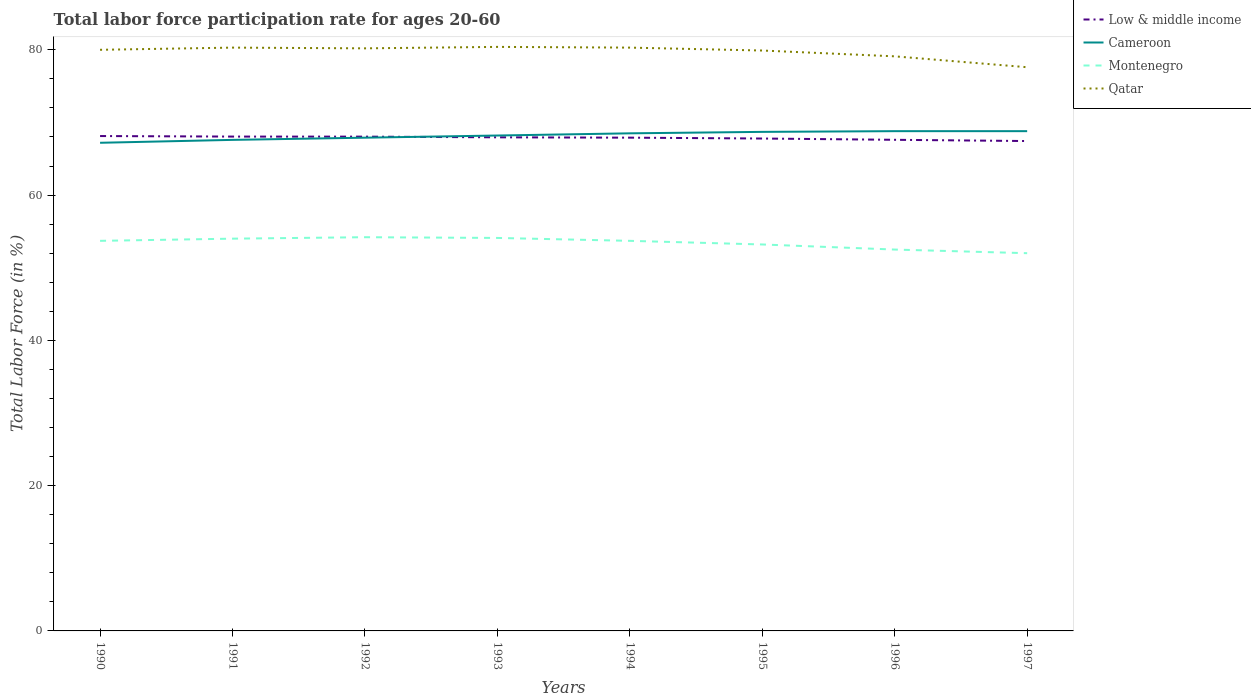Does the line corresponding to Montenegro intersect with the line corresponding to Cameroon?
Ensure brevity in your answer.  No. Is the number of lines equal to the number of legend labels?
Your answer should be compact. Yes. Across all years, what is the maximum labor force participation rate in Qatar?
Provide a succinct answer. 77.6. What is the total labor force participation rate in Montenegro in the graph?
Provide a succinct answer. 2.1. What is the difference between the highest and the second highest labor force participation rate in Montenegro?
Your answer should be very brief. 2.2. Is the labor force participation rate in Low & middle income strictly greater than the labor force participation rate in Montenegro over the years?
Your answer should be compact. No. How many years are there in the graph?
Make the answer very short. 8. What is the difference between two consecutive major ticks on the Y-axis?
Offer a terse response. 20. Does the graph contain any zero values?
Offer a very short reply. No. How many legend labels are there?
Your response must be concise. 4. How are the legend labels stacked?
Keep it short and to the point. Vertical. What is the title of the graph?
Your response must be concise. Total labor force participation rate for ages 20-60. What is the label or title of the Y-axis?
Give a very brief answer. Total Labor Force (in %). What is the Total Labor Force (in %) of Low & middle income in 1990?
Offer a terse response. 68.13. What is the Total Labor Force (in %) of Cameroon in 1990?
Provide a short and direct response. 67.2. What is the Total Labor Force (in %) in Montenegro in 1990?
Offer a very short reply. 53.7. What is the Total Labor Force (in %) in Low & middle income in 1991?
Your answer should be compact. 68.05. What is the Total Labor Force (in %) in Cameroon in 1991?
Your answer should be very brief. 67.6. What is the Total Labor Force (in %) of Qatar in 1991?
Your answer should be very brief. 80.3. What is the Total Labor Force (in %) of Low & middle income in 1992?
Provide a short and direct response. 68.05. What is the Total Labor Force (in %) in Cameroon in 1992?
Give a very brief answer. 67.9. What is the Total Labor Force (in %) in Montenegro in 1992?
Your response must be concise. 54.2. What is the Total Labor Force (in %) in Qatar in 1992?
Provide a succinct answer. 80.2. What is the Total Labor Force (in %) in Low & middle income in 1993?
Provide a short and direct response. 67.95. What is the Total Labor Force (in %) in Cameroon in 1993?
Ensure brevity in your answer.  68.2. What is the Total Labor Force (in %) of Montenegro in 1993?
Make the answer very short. 54.1. What is the Total Labor Force (in %) in Qatar in 1993?
Offer a terse response. 80.4. What is the Total Labor Force (in %) in Low & middle income in 1994?
Give a very brief answer. 67.9. What is the Total Labor Force (in %) in Cameroon in 1994?
Keep it short and to the point. 68.5. What is the Total Labor Force (in %) in Montenegro in 1994?
Make the answer very short. 53.7. What is the Total Labor Force (in %) of Qatar in 1994?
Make the answer very short. 80.3. What is the Total Labor Force (in %) of Low & middle income in 1995?
Offer a terse response. 67.79. What is the Total Labor Force (in %) of Cameroon in 1995?
Your answer should be compact. 68.7. What is the Total Labor Force (in %) in Montenegro in 1995?
Your answer should be compact. 53.2. What is the Total Labor Force (in %) in Qatar in 1995?
Make the answer very short. 79.9. What is the Total Labor Force (in %) of Low & middle income in 1996?
Ensure brevity in your answer.  67.61. What is the Total Labor Force (in %) in Cameroon in 1996?
Provide a short and direct response. 68.8. What is the Total Labor Force (in %) of Montenegro in 1996?
Make the answer very short. 52.5. What is the Total Labor Force (in %) in Qatar in 1996?
Your answer should be very brief. 79.1. What is the Total Labor Force (in %) in Low & middle income in 1997?
Your answer should be compact. 67.44. What is the Total Labor Force (in %) of Cameroon in 1997?
Your answer should be compact. 68.8. What is the Total Labor Force (in %) in Qatar in 1997?
Your answer should be very brief. 77.6. Across all years, what is the maximum Total Labor Force (in %) in Low & middle income?
Make the answer very short. 68.13. Across all years, what is the maximum Total Labor Force (in %) in Cameroon?
Your response must be concise. 68.8. Across all years, what is the maximum Total Labor Force (in %) of Montenegro?
Your response must be concise. 54.2. Across all years, what is the maximum Total Labor Force (in %) of Qatar?
Your answer should be compact. 80.4. Across all years, what is the minimum Total Labor Force (in %) of Low & middle income?
Give a very brief answer. 67.44. Across all years, what is the minimum Total Labor Force (in %) in Cameroon?
Offer a very short reply. 67.2. Across all years, what is the minimum Total Labor Force (in %) in Montenegro?
Offer a very short reply. 52. Across all years, what is the minimum Total Labor Force (in %) of Qatar?
Your answer should be compact. 77.6. What is the total Total Labor Force (in %) of Low & middle income in the graph?
Keep it short and to the point. 542.91. What is the total Total Labor Force (in %) in Cameroon in the graph?
Make the answer very short. 545.7. What is the total Total Labor Force (in %) in Montenegro in the graph?
Make the answer very short. 427.4. What is the total Total Labor Force (in %) in Qatar in the graph?
Provide a short and direct response. 637.8. What is the difference between the Total Labor Force (in %) of Low & middle income in 1990 and that in 1991?
Make the answer very short. 0.07. What is the difference between the Total Labor Force (in %) in Cameroon in 1990 and that in 1991?
Give a very brief answer. -0.4. What is the difference between the Total Labor Force (in %) of Montenegro in 1990 and that in 1991?
Keep it short and to the point. -0.3. What is the difference between the Total Labor Force (in %) of Qatar in 1990 and that in 1991?
Your answer should be compact. -0.3. What is the difference between the Total Labor Force (in %) of Low & middle income in 1990 and that in 1992?
Your response must be concise. 0.08. What is the difference between the Total Labor Force (in %) of Montenegro in 1990 and that in 1992?
Provide a succinct answer. -0.5. What is the difference between the Total Labor Force (in %) of Low & middle income in 1990 and that in 1993?
Give a very brief answer. 0.18. What is the difference between the Total Labor Force (in %) of Cameroon in 1990 and that in 1993?
Keep it short and to the point. -1. What is the difference between the Total Labor Force (in %) in Montenegro in 1990 and that in 1993?
Provide a short and direct response. -0.4. What is the difference between the Total Labor Force (in %) of Qatar in 1990 and that in 1993?
Your answer should be very brief. -0.4. What is the difference between the Total Labor Force (in %) in Low & middle income in 1990 and that in 1994?
Provide a short and direct response. 0.22. What is the difference between the Total Labor Force (in %) in Cameroon in 1990 and that in 1994?
Ensure brevity in your answer.  -1.3. What is the difference between the Total Labor Force (in %) of Montenegro in 1990 and that in 1994?
Your response must be concise. 0. What is the difference between the Total Labor Force (in %) in Low & middle income in 1990 and that in 1995?
Offer a very short reply. 0.34. What is the difference between the Total Labor Force (in %) of Montenegro in 1990 and that in 1995?
Offer a very short reply. 0.5. What is the difference between the Total Labor Force (in %) of Low & middle income in 1990 and that in 1996?
Make the answer very short. 0.52. What is the difference between the Total Labor Force (in %) in Cameroon in 1990 and that in 1996?
Give a very brief answer. -1.6. What is the difference between the Total Labor Force (in %) in Qatar in 1990 and that in 1996?
Offer a terse response. 0.9. What is the difference between the Total Labor Force (in %) in Low & middle income in 1990 and that in 1997?
Give a very brief answer. 0.69. What is the difference between the Total Labor Force (in %) in Low & middle income in 1991 and that in 1992?
Your answer should be compact. 0.01. What is the difference between the Total Labor Force (in %) in Cameroon in 1991 and that in 1992?
Give a very brief answer. -0.3. What is the difference between the Total Labor Force (in %) in Montenegro in 1991 and that in 1992?
Provide a short and direct response. -0.2. What is the difference between the Total Labor Force (in %) in Low & middle income in 1991 and that in 1993?
Your answer should be compact. 0.1. What is the difference between the Total Labor Force (in %) of Cameroon in 1991 and that in 1993?
Give a very brief answer. -0.6. What is the difference between the Total Labor Force (in %) in Montenegro in 1991 and that in 1993?
Your response must be concise. -0.1. What is the difference between the Total Labor Force (in %) in Low & middle income in 1991 and that in 1994?
Provide a short and direct response. 0.15. What is the difference between the Total Labor Force (in %) in Qatar in 1991 and that in 1994?
Provide a short and direct response. 0. What is the difference between the Total Labor Force (in %) in Low & middle income in 1991 and that in 1995?
Make the answer very short. 0.27. What is the difference between the Total Labor Force (in %) of Low & middle income in 1991 and that in 1996?
Offer a terse response. 0.44. What is the difference between the Total Labor Force (in %) in Low & middle income in 1991 and that in 1997?
Keep it short and to the point. 0.62. What is the difference between the Total Labor Force (in %) in Cameroon in 1991 and that in 1997?
Make the answer very short. -1.2. What is the difference between the Total Labor Force (in %) of Montenegro in 1991 and that in 1997?
Your response must be concise. 2. What is the difference between the Total Labor Force (in %) of Qatar in 1991 and that in 1997?
Ensure brevity in your answer.  2.7. What is the difference between the Total Labor Force (in %) of Low & middle income in 1992 and that in 1993?
Give a very brief answer. 0.1. What is the difference between the Total Labor Force (in %) of Cameroon in 1992 and that in 1993?
Your answer should be compact. -0.3. What is the difference between the Total Labor Force (in %) in Qatar in 1992 and that in 1993?
Your answer should be compact. -0.2. What is the difference between the Total Labor Force (in %) of Low & middle income in 1992 and that in 1994?
Ensure brevity in your answer.  0.14. What is the difference between the Total Labor Force (in %) in Cameroon in 1992 and that in 1994?
Offer a very short reply. -0.6. What is the difference between the Total Labor Force (in %) in Montenegro in 1992 and that in 1994?
Keep it short and to the point. 0.5. What is the difference between the Total Labor Force (in %) in Low & middle income in 1992 and that in 1995?
Make the answer very short. 0.26. What is the difference between the Total Labor Force (in %) in Low & middle income in 1992 and that in 1996?
Make the answer very short. 0.44. What is the difference between the Total Labor Force (in %) of Montenegro in 1992 and that in 1996?
Offer a terse response. 1.7. What is the difference between the Total Labor Force (in %) of Qatar in 1992 and that in 1996?
Your answer should be very brief. 1.1. What is the difference between the Total Labor Force (in %) of Low & middle income in 1992 and that in 1997?
Give a very brief answer. 0.61. What is the difference between the Total Labor Force (in %) in Montenegro in 1992 and that in 1997?
Keep it short and to the point. 2.2. What is the difference between the Total Labor Force (in %) in Qatar in 1992 and that in 1997?
Your answer should be compact. 2.6. What is the difference between the Total Labor Force (in %) in Low & middle income in 1993 and that in 1994?
Ensure brevity in your answer.  0.05. What is the difference between the Total Labor Force (in %) in Cameroon in 1993 and that in 1994?
Keep it short and to the point. -0.3. What is the difference between the Total Labor Force (in %) of Low & middle income in 1993 and that in 1995?
Your answer should be compact. 0.17. What is the difference between the Total Labor Force (in %) of Cameroon in 1993 and that in 1995?
Provide a short and direct response. -0.5. What is the difference between the Total Labor Force (in %) in Montenegro in 1993 and that in 1995?
Keep it short and to the point. 0.9. What is the difference between the Total Labor Force (in %) in Low & middle income in 1993 and that in 1996?
Your response must be concise. 0.34. What is the difference between the Total Labor Force (in %) in Cameroon in 1993 and that in 1996?
Provide a succinct answer. -0.6. What is the difference between the Total Labor Force (in %) of Montenegro in 1993 and that in 1996?
Ensure brevity in your answer.  1.6. What is the difference between the Total Labor Force (in %) in Qatar in 1993 and that in 1996?
Ensure brevity in your answer.  1.3. What is the difference between the Total Labor Force (in %) of Low & middle income in 1993 and that in 1997?
Offer a terse response. 0.51. What is the difference between the Total Labor Force (in %) of Montenegro in 1993 and that in 1997?
Make the answer very short. 2.1. What is the difference between the Total Labor Force (in %) of Qatar in 1993 and that in 1997?
Your answer should be compact. 2.8. What is the difference between the Total Labor Force (in %) in Low & middle income in 1994 and that in 1995?
Provide a succinct answer. 0.12. What is the difference between the Total Labor Force (in %) of Qatar in 1994 and that in 1995?
Your answer should be very brief. 0.4. What is the difference between the Total Labor Force (in %) of Low & middle income in 1994 and that in 1996?
Ensure brevity in your answer.  0.29. What is the difference between the Total Labor Force (in %) in Montenegro in 1994 and that in 1996?
Your response must be concise. 1.2. What is the difference between the Total Labor Force (in %) in Qatar in 1994 and that in 1996?
Your answer should be compact. 1.2. What is the difference between the Total Labor Force (in %) of Low & middle income in 1994 and that in 1997?
Ensure brevity in your answer.  0.47. What is the difference between the Total Labor Force (in %) in Low & middle income in 1995 and that in 1996?
Keep it short and to the point. 0.18. What is the difference between the Total Labor Force (in %) in Cameroon in 1995 and that in 1996?
Your answer should be very brief. -0.1. What is the difference between the Total Labor Force (in %) of Low & middle income in 1995 and that in 1997?
Offer a terse response. 0.35. What is the difference between the Total Labor Force (in %) of Montenegro in 1995 and that in 1997?
Your response must be concise. 1.2. What is the difference between the Total Labor Force (in %) of Qatar in 1995 and that in 1997?
Offer a terse response. 2.3. What is the difference between the Total Labor Force (in %) of Low & middle income in 1996 and that in 1997?
Your answer should be compact. 0.17. What is the difference between the Total Labor Force (in %) of Cameroon in 1996 and that in 1997?
Offer a terse response. 0. What is the difference between the Total Labor Force (in %) of Low & middle income in 1990 and the Total Labor Force (in %) of Cameroon in 1991?
Provide a succinct answer. 0.53. What is the difference between the Total Labor Force (in %) of Low & middle income in 1990 and the Total Labor Force (in %) of Montenegro in 1991?
Give a very brief answer. 14.13. What is the difference between the Total Labor Force (in %) of Low & middle income in 1990 and the Total Labor Force (in %) of Qatar in 1991?
Your answer should be compact. -12.17. What is the difference between the Total Labor Force (in %) in Montenegro in 1990 and the Total Labor Force (in %) in Qatar in 1991?
Keep it short and to the point. -26.6. What is the difference between the Total Labor Force (in %) of Low & middle income in 1990 and the Total Labor Force (in %) of Cameroon in 1992?
Provide a succinct answer. 0.23. What is the difference between the Total Labor Force (in %) in Low & middle income in 1990 and the Total Labor Force (in %) in Montenegro in 1992?
Your answer should be compact. 13.93. What is the difference between the Total Labor Force (in %) of Low & middle income in 1990 and the Total Labor Force (in %) of Qatar in 1992?
Your answer should be very brief. -12.07. What is the difference between the Total Labor Force (in %) of Montenegro in 1990 and the Total Labor Force (in %) of Qatar in 1992?
Make the answer very short. -26.5. What is the difference between the Total Labor Force (in %) in Low & middle income in 1990 and the Total Labor Force (in %) in Cameroon in 1993?
Your answer should be very brief. -0.07. What is the difference between the Total Labor Force (in %) in Low & middle income in 1990 and the Total Labor Force (in %) in Montenegro in 1993?
Provide a succinct answer. 14.03. What is the difference between the Total Labor Force (in %) of Low & middle income in 1990 and the Total Labor Force (in %) of Qatar in 1993?
Provide a succinct answer. -12.27. What is the difference between the Total Labor Force (in %) in Montenegro in 1990 and the Total Labor Force (in %) in Qatar in 1993?
Offer a very short reply. -26.7. What is the difference between the Total Labor Force (in %) in Low & middle income in 1990 and the Total Labor Force (in %) in Cameroon in 1994?
Your answer should be compact. -0.37. What is the difference between the Total Labor Force (in %) in Low & middle income in 1990 and the Total Labor Force (in %) in Montenegro in 1994?
Keep it short and to the point. 14.43. What is the difference between the Total Labor Force (in %) in Low & middle income in 1990 and the Total Labor Force (in %) in Qatar in 1994?
Give a very brief answer. -12.17. What is the difference between the Total Labor Force (in %) of Cameroon in 1990 and the Total Labor Force (in %) of Montenegro in 1994?
Keep it short and to the point. 13.5. What is the difference between the Total Labor Force (in %) of Montenegro in 1990 and the Total Labor Force (in %) of Qatar in 1994?
Keep it short and to the point. -26.6. What is the difference between the Total Labor Force (in %) in Low & middle income in 1990 and the Total Labor Force (in %) in Cameroon in 1995?
Your answer should be compact. -0.57. What is the difference between the Total Labor Force (in %) of Low & middle income in 1990 and the Total Labor Force (in %) of Montenegro in 1995?
Offer a very short reply. 14.93. What is the difference between the Total Labor Force (in %) of Low & middle income in 1990 and the Total Labor Force (in %) of Qatar in 1995?
Provide a succinct answer. -11.77. What is the difference between the Total Labor Force (in %) of Cameroon in 1990 and the Total Labor Force (in %) of Qatar in 1995?
Your answer should be compact. -12.7. What is the difference between the Total Labor Force (in %) in Montenegro in 1990 and the Total Labor Force (in %) in Qatar in 1995?
Provide a short and direct response. -26.2. What is the difference between the Total Labor Force (in %) in Low & middle income in 1990 and the Total Labor Force (in %) in Cameroon in 1996?
Your answer should be compact. -0.67. What is the difference between the Total Labor Force (in %) of Low & middle income in 1990 and the Total Labor Force (in %) of Montenegro in 1996?
Give a very brief answer. 15.63. What is the difference between the Total Labor Force (in %) in Low & middle income in 1990 and the Total Labor Force (in %) in Qatar in 1996?
Your answer should be very brief. -10.97. What is the difference between the Total Labor Force (in %) in Cameroon in 1990 and the Total Labor Force (in %) in Montenegro in 1996?
Your answer should be very brief. 14.7. What is the difference between the Total Labor Force (in %) in Montenegro in 1990 and the Total Labor Force (in %) in Qatar in 1996?
Offer a terse response. -25.4. What is the difference between the Total Labor Force (in %) of Low & middle income in 1990 and the Total Labor Force (in %) of Cameroon in 1997?
Offer a very short reply. -0.67. What is the difference between the Total Labor Force (in %) of Low & middle income in 1990 and the Total Labor Force (in %) of Montenegro in 1997?
Ensure brevity in your answer.  16.13. What is the difference between the Total Labor Force (in %) in Low & middle income in 1990 and the Total Labor Force (in %) in Qatar in 1997?
Give a very brief answer. -9.47. What is the difference between the Total Labor Force (in %) of Montenegro in 1990 and the Total Labor Force (in %) of Qatar in 1997?
Your response must be concise. -23.9. What is the difference between the Total Labor Force (in %) in Low & middle income in 1991 and the Total Labor Force (in %) in Cameroon in 1992?
Give a very brief answer. 0.15. What is the difference between the Total Labor Force (in %) in Low & middle income in 1991 and the Total Labor Force (in %) in Montenegro in 1992?
Offer a very short reply. 13.85. What is the difference between the Total Labor Force (in %) in Low & middle income in 1991 and the Total Labor Force (in %) in Qatar in 1992?
Provide a succinct answer. -12.15. What is the difference between the Total Labor Force (in %) in Montenegro in 1991 and the Total Labor Force (in %) in Qatar in 1992?
Your response must be concise. -26.2. What is the difference between the Total Labor Force (in %) in Low & middle income in 1991 and the Total Labor Force (in %) in Cameroon in 1993?
Make the answer very short. -0.15. What is the difference between the Total Labor Force (in %) in Low & middle income in 1991 and the Total Labor Force (in %) in Montenegro in 1993?
Your answer should be very brief. 13.95. What is the difference between the Total Labor Force (in %) in Low & middle income in 1991 and the Total Labor Force (in %) in Qatar in 1993?
Provide a succinct answer. -12.35. What is the difference between the Total Labor Force (in %) in Montenegro in 1991 and the Total Labor Force (in %) in Qatar in 1993?
Offer a terse response. -26.4. What is the difference between the Total Labor Force (in %) of Low & middle income in 1991 and the Total Labor Force (in %) of Cameroon in 1994?
Make the answer very short. -0.45. What is the difference between the Total Labor Force (in %) of Low & middle income in 1991 and the Total Labor Force (in %) of Montenegro in 1994?
Ensure brevity in your answer.  14.35. What is the difference between the Total Labor Force (in %) of Low & middle income in 1991 and the Total Labor Force (in %) of Qatar in 1994?
Offer a very short reply. -12.25. What is the difference between the Total Labor Force (in %) in Cameroon in 1991 and the Total Labor Force (in %) in Qatar in 1994?
Provide a short and direct response. -12.7. What is the difference between the Total Labor Force (in %) of Montenegro in 1991 and the Total Labor Force (in %) of Qatar in 1994?
Provide a short and direct response. -26.3. What is the difference between the Total Labor Force (in %) of Low & middle income in 1991 and the Total Labor Force (in %) of Cameroon in 1995?
Ensure brevity in your answer.  -0.65. What is the difference between the Total Labor Force (in %) of Low & middle income in 1991 and the Total Labor Force (in %) of Montenegro in 1995?
Provide a succinct answer. 14.85. What is the difference between the Total Labor Force (in %) in Low & middle income in 1991 and the Total Labor Force (in %) in Qatar in 1995?
Your answer should be compact. -11.85. What is the difference between the Total Labor Force (in %) in Cameroon in 1991 and the Total Labor Force (in %) in Montenegro in 1995?
Make the answer very short. 14.4. What is the difference between the Total Labor Force (in %) in Montenegro in 1991 and the Total Labor Force (in %) in Qatar in 1995?
Your answer should be compact. -25.9. What is the difference between the Total Labor Force (in %) in Low & middle income in 1991 and the Total Labor Force (in %) in Cameroon in 1996?
Offer a terse response. -0.75. What is the difference between the Total Labor Force (in %) in Low & middle income in 1991 and the Total Labor Force (in %) in Montenegro in 1996?
Provide a succinct answer. 15.55. What is the difference between the Total Labor Force (in %) of Low & middle income in 1991 and the Total Labor Force (in %) of Qatar in 1996?
Offer a terse response. -11.05. What is the difference between the Total Labor Force (in %) in Cameroon in 1991 and the Total Labor Force (in %) in Qatar in 1996?
Provide a short and direct response. -11.5. What is the difference between the Total Labor Force (in %) of Montenegro in 1991 and the Total Labor Force (in %) of Qatar in 1996?
Offer a very short reply. -25.1. What is the difference between the Total Labor Force (in %) in Low & middle income in 1991 and the Total Labor Force (in %) in Cameroon in 1997?
Your answer should be compact. -0.75. What is the difference between the Total Labor Force (in %) of Low & middle income in 1991 and the Total Labor Force (in %) of Montenegro in 1997?
Give a very brief answer. 16.05. What is the difference between the Total Labor Force (in %) in Low & middle income in 1991 and the Total Labor Force (in %) in Qatar in 1997?
Ensure brevity in your answer.  -9.55. What is the difference between the Total Labor Force (in %) in Cameroon in 1991 and the Total Labor Force (in %) in Qatar in 1997?
Keep it short and to the point. -10. What is the difference between the Total Labor Force (in %) in Montenegro in 1991 and the Total Labor Force (in %) in Qatar in 1997?
Offer a terse response. -23.6. What is the difference between the Total Labor Force (in %) of Low & middle income in 1992 and the Total Labor Force (in %) of Cameroon in 1993?
Make the answer very short. -0.15. What is the difference between the Total Labor Force (in %) of Low & middle income in 1992 and the Total Labor Force (in %) of Montenegro in 1993?
Give a very brief answer. 13.95. What is the difference between the Total Labor Force (in %) in Low & middle income in 1992 and the Total Labor Force (in %) in Qatar in 1993?
Your answer should be compact. -12.35. What is the difference between the Total Labor Force (in %) of Cameroon in 1992 and the Total Labor Force (in %) of Montenegro in 1993?
Ensure brevity in your answer.  13.8. What is the difference between the Total Labor Force (in %) of Montenegro in 1992 and the Total Labor Force (in %) of Qatar in 1993?
Offer a terse response. -26.2. What is the difference between the Total Labor Force (in %) of Low & middle income in 1992 and the Total Labor Force (in %) of Cameroon in 1994?
Your answer should be very brief. -0.45. What is the difference between the Total Labor Force (in %) of Low & middle income in 1992 and the Total Labor Force (in %) of Montenegro in 1994?
Offer a very short reply. 14.35. What is the difference between the Total Labor Force (in %) in Low & middle income in 1992 and the Total Labor Force (in %) in Qatar in 1994?
Offer a very short reply. -12.25. What is the difference between the Total Labor Force (in %) in Cameroon in 1992 and the Total Labor Force (in %) in Montenegro in 1994?
Your answer should be compact. 14.2. What is the difference between the Total Labor Force (in %) of Montenegro in 1992 and the Total Labor Force (in %) of Qatar in 1994?
Give a very brief answer. -26.1. What is the difference between the Total Labor Force (in %) of Low & middle income in 1992 and the Total Labor Force (in %) of Cameroon in 1995?
Your response must be concise. -0.65. What is the difference between the Total Labor Force (in %) of Low & middle income in 1992 and the Total Labor Force (in %) of Montenegro in 1995?
Make the answer very short. 14.85. What is the difference between the Total Labor Force (in %) in Low & middle income in 1992 and the Total Labor Force (in %) in Qatar in 1995?
Ensure brevity in your answer.  -11.85. What is the difference between the Total Labor Force (in %) of Cameroon in 1992 and the Total Labor Force (in %) of Montenegro in 1995?
Your answer should be very brief. 14.7. What is the difference between the Total Labor Force (in %) in Montenegro in 1992 and the Total Labor Force (in %) in Qatar in 1995?
Keep it short and to the point. -25.7. What is the difference between the Total Labor Force (in %) in Low & middle income in 1992 and the Total Labor Force (in %) in Cameroon in 1996?
Your response must be concise. -0.75. What is the difference between the Total Labor Force (in %) in Low & middle income in 1992 and the Total Labor Force (in %) in Montenegro in 1996?
Give a very brief answer. 15.55. What is the difference between the Total Labor Force (in %) of Low & middle income in 1992 and the Total Labor Force (in %) of Qatar in 1996?
Your answer should be very brief. -11.05. What is the difference between the Total Labor Force (in %) in Cameroon in 1992 and the Total Labor Force (in %) in Montenegro in 1996?
Keep it short and to the point. 15.4. What is the difference between the Total Labor Force (in %) of Montenegro in 1992 and the Total Labor Force (in %) of Qatar in 1996?
Make the answer very short. -24.9. What is the difference between the Total Labor Force (in %) of Low & middle income in 1992 and the Total Labor Force (in %) of Cameroon in 1997?
Give a very brief answer. -0.75. What is the difference between the Total Labor Force (in %) in Low & middle income in 1992 and the Total Labor Force (in %) in Montenegro in 1997?
Keep it short and to the point. 16.05. What is the difference between the Total Labor Force (in %) of Low & middle income in 1992 and the Total Labor Force (in %) of Qatar in 1997?
Ensure brevity in your answer.  -9.55. What is the difference between the Total Labor Force (in %) of Montenegro in 1992 and the Total Labor Force (in %) of Qatar in 1997?
Provide a short and direct response. -23.4. What is the difference between the Total Labor Force (in %) of Low & middle income in 1993 and the Total Labor Force (in %) of Cameroon in 1994?
Offer a very short reply. -0.55. What is the difference between the Total Labor Force (in %) in Low & middle income in 1993 and the Total Labor Force (in %) in Montenegro in 1994?
Give a very brief answer. 14.25. What is the difference between the Total Labor Force (in %) of Low & middle income in 1993 and the Total Labor Force (in %) of Qatar in 1994?
Keep it short and to the point. -12.35. What is the difference between the Total Labor Force (in %) of Montenegro in 1993 and the Total Labor Force (in %) of Qatar in 1994?
Offer a very short reply. -26.2. What is the difference between the Total Labor Force (in %) in Low & middle income in 1993 and the Total Labor Force (in %) in Cameroon in 1995?
Your answer should be very brief. -0.75. What is the difference between the Total Labor Force (in %) of Low & middle income in 1993 and the Total Labor Force (in %) of Montenegro in 1995?
Your answer should be very brief. 14.75. What is the difference between the Total Labor Force (in %) in Low & middle income in 1993 and the Total Labor Force (in %) in Qatar in 1995?
Offer a very short reply. -11.95. What is the difference between the Total Labor Force (in %) of Montenegro in 1993 and the Total Labor Force (in %) of Qatar in 1995?
Keep it short and to the point. -25.8. What is the difference between the Total Labor Force (in %) in Low & middle income in 1993 and the Total Labor Force (in %) in Cameroon in 1996?
Your response must be concise. -0.85. What is the difference between the Total Labor Force (in %) of Low & middle income in 1993 and the Total Labor Force (in %) of Montenegro in 1996?
Make the answer very short. 15.45. What is the difference between the Total Labor Force (in %) in Low & middle income in 1993 and the Total Labor Force (in %) in Qatar in 1996?
Offer a very short reply. -11.15. What is the difference between the Total Labor Force (in %) of Cameroon in 1993 and the Total Labor Force (in %) of Qatar in 1996?
Keep it short and to the point. -10.9. What is the difference between the Total Labor Force (in %) in Low & middle income in 1993 and the Total Labor Force (in %) in Cameroon in 1997?
Offer a terse response. -0.85. What is the difference between the Total Labor Force (in %) in Low & middle income in 1993 and the Total Labor Force (in %) in Montenegro in 1997?
Make the answer very short. 15.95. What is the difference between the Total Labor Force (in %) in Low & middle income in 1993 and the Total Labor Force (in %) in Qatar in 1997?
Your answer should be very brief. -9.65. What is the difference between the Total Labor Force (in %) of Cameroon in 1993 and the Total Labor Force (in %) of Montenegro in 1997?
Give a very brief answer. 16.2. What is the difference between the Total Labor Force (in %) in Montenegro in 1993 and the Total Labor Force (in %) in Qatar in 1997?
Make the answer very short. -23.5. What is the difference between the Total Labor Force (in %) of Low & middle income in 1994 and the Total Labor Force (in %) of Cameroon in 1995?
Keep it short and to the point. -0.8. What is the difference between the Total Labor Force (in %) of Low & middle income in 1994 and the Total Labor Force (in %) of Montenegro in 1995?
Ensure brevity in your answer.  14.7. What is the difference between the Total Labor Force (in %) of Low & middle income in 1994 and the Total Labor Force (in %) of Qatar in 1995?
Make the answer very short. -12. What is the difference between the Total Labor Force (in %) of Cameroon in 1994 and the Total Labor Force (in %) of Montenegro in 1995?
Your answer should be compact. 15.3. What is the difference between the Total Labor Force (in %) in Montenegro in 1994 and the Total Labor Force (in %) in Qatar in 1995?
Keep it short and to the point. -26.2. What is the difference between the Total Labor Force (in %) in Low & middle income in 1994 and the Total Labor Force (in %) in Cameroon in 1996?
Your answer should be very brief. -0.9. What is the difference between the Total Labor Force (in %) of Low & middle income in 1994 and the Total Labor Force (in %) of Montenegro in 1996?
Provide a short and direct response. 15.4. What is the difference between the Total Labor Force (in %) of Low & middle income in 1994 and the Total Labor Force (in %) of Qatar in 1996?
Your answer should be compact. -11.2. What is the difference between the Total Labor Force (in %) in Montenegro in 1994 and the Total Labor Force (in %) in Qatar in 1996?
Offer a very short reply. -25.4. What is the difference between the Total Labor Force (in %) in Low & middle income in 1994 and the Total Labor Force (in %) in Cameroon in 1997?
Ensure brevity in your answer.  -0.9. What is the difference between the Total Labor Force (in %) of Low & middle income in 1994 and the Total Labor Force (in %) of Montenegro in 1997?
Give a very brief answer. 15.9. What is the difference between the Total Labor Force (in %) of Low & middle income in 1994 and the Total Labor Force (in %) of Qatar in 1997?
Your answer should be compact. -9.7. What is the difference between the Total Labor Force (in %) in Cameroon in 1994 and the Total Labor Force (in %) in Montenegro in 1997?
Offer a terse response. 16.5. What is the difference between the Total Labor Force (in %) in Cameroon in 1994 and the Total Labor Force (in %) in Qatar in 1997?
Make the answer very short. -9.1. What is the difference between the Total Labor Force (in %) in Montenegro in 1994 and the Total Labor Force (in %) in Qatar in 1997?
Make the answer very short. -23.9. What is the difference between the Total Labor Force (in %) of Low & middle income in 1995 and the Total Labor Force (in %) of Cameroon in 1996?
Provide a short and direct response. -1.01. What is the difference between the Total Labor Force (in %) of Low & middle income in 1995 and the Total Labor Force (in %) of Montenegro in 1996?
Your answer should be compact. 15.29. What is the difference between the Total Labor Force (in %) in Low & middle income in 1995 and the Total Labor Force (in %) in Qatar in 1996?
Your response must be concise. -11.31. What is the difference between the Total Labor Force (in %) in Cameroon in 1995 and the Total Labor Force (in %) in Montenegro in 1996?
Provide a succinct answer. 16.2. What is the difference between the Total Labor Force (in %) of Montenegro in 1995 and the Total Labor Force (in %) of Qatar in 1996?
Your response must be concise. -25.9. What is the difference between the Total Labor Force (in %) in Low & middle income in 1995 and the Total Labor Force (in %) in Cameroon in 1997?
Ensure brevity in your answer.  -1.01. What is the difference between the Total Labor Force (in %) in Low & middle income in 1995 and the Total Labor Force (in %) in Montenegro in 1997?
Your answer should be compact. 15.79. What is the difference between the Total Labor Force (in %) in Low & middle income in 1995 and the Total Labor Force (in %) in Qatar in 1997?
Ensure brevity in your answer.  -9.81. What is the difference between the Total Labor Force (in %) of Cameroon in 1995 and the Total Labor Force (in %) of Montenegro in 1997?
Provide a short and direct response. 16.7. What is the difference between the Total Labor Force (in %) in Montenegro in 1995 and the Total Labor Force (in %) in Qatar in 1997?
Keep it short and to the point. -24.4. What is the difference between the Total Labor Force (in %) of Low & middle income in 1996 and the Total Labor Force (in %) of Cameroon in 1997?
Your answer should be very brief. -1.19. What is the difference between the Total Labor Force (in %) in Low & middle income in 1996 and the Total Labor Force (in %) in Montenegro in 1997?
Ensure brevity in your answer.  15.61. What is the difference between the Total Labor Force (in %) of Low & middle income in 1996 and the Total Labor Force (in %) of Qatar in 1997?
Ensure brevity in your answer.  -9.99. What is the difference between the Total Labor Force (in %) in Cameroon in 1996 and the Total Labor Force (in %) in Qatar in 1997?
Ensure brevity in your answer.  -8.8. What is the difference between the Total Labor Force (in %) of Montenegro in 1996 and the Total Labor Force (in %) of Qatar in 1997?
Make the answer very short. -25.1. What is the average Total Labor Force (in %) of Low & middle income per year?
Make the answer very short. 67.86. What is the average Total Labor Force (in %) in Cameroon per year?
Provide a succinct answer. 68.21. What is the average Total Labor Force (in %) in Montenegro per year?
Make the answer very short. 53.42. What is the average Total Labor Force (in %) of Qatar per year?
Ensure brevity in your answer.  79.72. In the year 1990, what is the difference between the Total Labor Force (in %) of Low & middle income and Total Labor Force (in %) of Cameroon?
Give a very brief answer. 0.93. In the year 1990, what is the difference between the Total Labor Force (in %) of Low & middle income and Total Labor Force (in %) of Montenegro?
Provide a succinct answer. 14.43. In the year 1990, what is the difference between the Total Labor Force (in %) of Low & middle income and Total Labor Force (in %) of Qatar?
Give a very brief answer. -11.87. In the year 1990, what is the difference between the Total Labor Force (in %) in Cameroon and Total Labor Force (in %) in Qatar?
Provide a short and direct response. -12.8. In the year 1990, what is the difference between the Total Labor Force (in %) in Montenegro and Total Labor Force (in %) in Qatar?
Offer a terse response. -26.3. In the year 1991, what is the difference between the Total Labor Force (in %) in Low & middle income and Total Labor Force (in %) in Cameroon?
Keep it short and to the point. 0.45. In the year 1991, what is the difference between the Total Labor Force (in %) of Low & middle income and Total Labor Force (in %) of Montenegro?
Your answer should be compact. 14.05. In the year 1991, what is the difference between the Total Labor Force (in %) in Low & middle income and Total Labor Force (in %) in Qatar?
Offer a very short reply. -12.25. In the year 1991, what is the difference between the Total Labor Force (in %) of Cameroon and Total Labor Force (in %) of Montenegro?
Give a very brief answer. 13.6. In the year 1991, what is the difference between the Total Labor Force (in %) in Cameroon and Total Labor Force (in %) in Qatar?
Provide a succinct answer. -12.7. In the year 1991, what is the difference between the Total Labor Force (in %) in Montenegro and Total Labor Force (in %) in Qatar?
Offer a very short reply. -26.3. In the year 1992, what is the difference between the Total Labor Force (in %) in Low & middle income and Total Labor Force (in %) in Cameroon?
Your answer should be very brief. 0.15. In the year 1992, what is the difference between the Total Labor Force (in %) in Low & middle income and Total Labor Force (in %) in Montenegro?
Give a very brief answer. 13.85. In the year 1992, what is the difference between the Total Labor Force (in %) in Low & middle income and Total Labor Force (in %) in Qatar?
Your answer should be compact. -12.15. In the year 1992, what is the difference between the Total Labor Force (in %) of Cameroon and Total Labor Force (in %) of Montenegro?
Offer a terse response. 13.7. In the year 1993, what is the difference between the Total Labor Force (in %) of Low & middle income and Total Labor Force (in %) of Cameroon?
Offer a very short reply. -0.25. In the year 1993, what is the difference between the Total Labor Force (in %) of Low & middle income and Total Labor Force (in %) of Montenegro?
Offer a terse response. 13.85. In the year 1993, what is the difference between the Total Labor Force (in %) in Low & middle income and Total Labor Force (in %) in Qatar?
Your answer should be compact. -12.45. In the year 1993, what is the difference between the Total Labor Force (in %) in Montenegro and Total Labor Force (in %) in Qatar?
Provide a short and direct response. -26.3. In the year 1994, what is the difference between the Total Labor Force (in %) of Low & middle income and Total Labor Force (in %) of Cameroon?
Offer a very short reply. -0.6. In the year 1994, what is the difference between the Total Labor Force (in %) in Low & middle income and Total Labor Force (in %) in Montenegro?
Ensure brevity in your answer.  14.2. In the year 1994, what is the difference between the Total Labor Force (in %) in Low & middle income and Total Labor Force (in %) in Qatar?
Keep it short and to the point. -12.4. In the year 1994, what is the difference between the Total Labor Force (in %) of Montenegro and Total Labor Force (in %) of Qatar?
Provide a succinct answer. -26.6. In the year 1995, what is the difference between the Total Labor Force (in %) in Low & middle income and Total Labor Force (in %) in Cameroon?
Provide a short and direct response. -0.91. In the year 1995, what is the difference between the Total Labor Force (in %) of Low & middle income and Total Labor Force (in %) of Montenegro?
Your answer should be very brief. 14.59. In the year 1995, what is the difference between the Total Labor Force (in %) in Low & middle income and Total Labor Force (in %) in Qatar?
Your response must be concise. -12.11. In the year 1995, what is the difference between the Total Labor Force (in %) in Cameroon and Total Labor Force (in %) in Qatar?
Ensure brevity in your answer.  -11.2. In the year 1995, what is the difference between the Total Labor Force (in %) of Montenegro and Total Labor Force (in %) of Qatar?
Ensure brevity in your answer.  -26.7. In the year 1996, what is the difference between the Total Labor Force (in %) in Low & middle income and Total Labor Force (in %) in Cameroon?
Offer a very short reply. -1.19. In the year 1996, what is the difference between the Total Labor Force (in %) in Low & middle income and Total Labor Force (in %) in Montenegro?
Ensure brevity in your answer.  15.11. In the year 1996, what is the difference between the Total Labor Force (in %) in Low & middle income and Total Labor Force (in %) in Qatar?
Make the answer very short. -11.49. In the year 1996, what is the difference between the Total Labor Force (in %) in Cameroon and Total Labor Force (in %) in Qatar?
Your answer should be very brief. -10.3. In the year 1996, what is the difference between the Total Labor Force (in %) of Montenegro and Total Labor Force (in %) of Qatar?
Ensure brevity in your answer.  -26.6. In the year 1997, what is the difference between the Total Labor Force (in %) in Low & middle income and Total Labor Force (in %) in Cameroon?
Your answer should be compact. -1.36. In the year 1997, what is the difference between the Total Labor Force (in %) in Low & middle income and Total Labor Force (in %) in Montenegro?
Make the answer very short. 15.44. In the year 1997, what is the difference between the Total Labor Force (in %) in Low & middle income and Total Labor Force (in %) in Qatar?
Your response must be concise. -10.16. In the year 1997, what is the difference between the Total Labor Force (in %) of Cameroon and Total Labor Force (in %) of Montenegro?
Your answer should be compact. 16.8. In the year 1997, what is the difference between the Total Labor Force (in %) of Cameroon and Total Labor Force (in %) of Qatar?
Offer a terse response. -8.8. In the year 1997, what is the difference between the Total Labor Force (in %) of Montenegro and Total Labor Force (in %) of Qatar?
Your response must be concise. -25.6. What is the ratio of the Total Labor Force (in %) in Cameroon in 1990 to that in 1991?
Ensure brevity in your answer.  0.99. What is the ratio of the Total Labor Force (in %) of Qatar in 1990 to that in 1991?
Ensure brevity in your answer.  1. What is the ratio of the Total Labor Force (in %) in Montenegro in 1990 to that in 1992?
Provide a succinct answer. 0.99. What is the ratio of the Total Labor Force (in %) of Cameroon in 1990 to that in 1993?
Provide a short and direct response. 0.99. What is the ratio of the Total Labor Force (in %) of Qatar in 1990 to that in 1993?
Make the answer very short. 0.99. What is the ratio of the Total Labor Force (in %) in Montenegro in 1990 to that in 1994?
Offer a terse response. 1. What is the ratio of the Total Labor Force (in %) in Qatar in 1990 to that in 1994?
Provide a short and direct response. 1. What is the ratio of the Total Labor Force (in %) of Cameroon in 1990 to that in 1995?
Your response must be concise. 0.98. What is the ratio of the Total Labor Force (in %) in Montenegro in 1990 to that in 1995?
Give a very brief answer. 1.01. What is the ratio of the Total Labor Force (in %) in Qatar in 1990 to that in 1995?
Offer a very short reply. 1. What is the ratio of the Total Labor Force (in %) in Low & middle income in 1990 to that in 1996?
Offer a terse response. 1.01. What is the ratio of the Total Labor Force (in %) of Cameroon in 1990 to that in 1996?
Your answer should be compact. 0.98. What is the ratio of the Total Labor Force (in %) of Montenegro in 1990 to that in 1996?
Ensure brevity in your answer.  1.02. What is the ratio of the Total Labor Force (in %) of Qatar in 1990 to that in 1996?
Ensure brevity in your answer.  1.01. What is the ratio of the Total Labor Force (in %) of Low & middle income in 1990 to that in 1997?
Offer a very short reply. 1.01. What is the ratio of the Total Labor Force (in %) in Cameroon in 1990 to that in 1997?
Make the answer very short. 0.98. What is the ratio of the Total Labor Force (in %) of Montenegro in 1990 to that in 1997?
Your answer should be very brief. 1.03. What is the ratio of the Total Labor Force (in %) in Qatar in 1990 to that in 1997?
Ensure brevity in your answer.  1.03. What is the ratio of the Total Labor Force (in %) of Cameroon in 1991 to that in 1992?
Your answer should be compact. 1. What is the ratio of the Total Labor Force (in %) of Montenegro in 1991 to that in 1992?
Ensure brevity in your answer.  1. What is the ratio of the Total Labor Force (in %) in Qatar in 1991 to that in 1993?
Give a very brief answer. 1. What is the ratio of the Total Labor Force (in %) in Cameroon in 1991 to that in 1994?
Ensure brevity in your answer.  0.99. What is the ratio of the Total Labor Force (in %) of Montenegro in 1991 to that in 1994?
Your answer should be very brief. 1.01. What is the ratio of the Total Labor Force (in %) of Low & middle income in 1991 to that in 1995?
Offer a very short reply. 1. What is the ratio of the Total Labor Force (in %) in Cameroon in 1991 to that in 1995?
Your answer should be compact. 0.98. What is the ratio of the Total Labor Force (in %) of Qatar in 1991 to that in 1995?
Offer a very short reply. 1. What is the ratio of the Total Labor Force (in %) in Low & middle income in 1991 to that in 1996?
Make the answer very short. 1.01. What is the ratio of the Total Labor Force (in %) in Cameroon in 1991 to that in 1996?
Provide a short and direct response. 0.98. What is the ratio of the Total Labor Force (in %) in Montenegro in 1991 to that in 1996?
Ensure brevity in your answer.  1.03. What is the ratio of the Total Labor Force (in %) of Qatar in 1991 to that in 1996?
Provide a succinct answer. 1.02. What is the ratio of the Total Labor Force (in %) of Low & middle income in 1991 to that in 1997?
Provide a short and direct response. 1.01. What is the ratio of the Total Labor Force (in %) in Cameroon in 1991 to that in 1997?
Keep it short and to the point. 0.98. What is the ratio of the Total Labor Force (in %) of Qatar in 1991 to that in 1997?
Your answer should be very brief. 1.03. What is the ratio of the Total Labor Force (in %) of Montenegro in 1992 to that in 1993?
Provide a succinct answer. 1. What is the ratio of the Total Labor Force (in %) of Qatar in 1992 to that in 1993?
Offer a terse response. 1. What is the ratio of the Total Labor Force (in %) in Low & middle income in 1992 to that in 1994?
Offer a very short reply. 1. What is the ratio of the Total Labor Force (in %) of Montenegro in 1992 to that in 1994?
Keep it short and to the point. 1.01. What is the ratio of the Total Labor Force (in %) in Low & middle income in 1992 to that in 1995?
Provide a succinct answer. 1. What is the ratio of the Total Labor Force (in %) in Cameroon in 1992 to that in 1995?
Keep it short and to the point. 0.99. What is the ratio of the Total Labor Force (in %) in Montenegro in 1992 to that in 1995?
Keep it short and to the point. 1.02. What is the ratio of the Total Labor Force (in %) in Qatar in 1992 to that in 1995?
Your answer should be compact. 1. What is the ratio of the Total Labor Force (in %) in Low & middle income in 1992 to that in 1996?
Your response must be concise. 1.01. What is the ratio of the Total Labor Force (in %) in Cameroon in 1992 to that in 1996?
Your response must be concise. 0.99. What is the ratio of the Total Labor Force (in %) of Montenegro in 1992 to that in 1996?
Offer a terse response. 1.03. What is the ratio of the Total Labor Force (in %) of Qatar in 1992 to that in 1996?
Offer a very short reply. 1.01. What is the ratio of the Total Labor Force (in %) of Low & middle income in 1992 to that in 1997?
Provide a succinct answer. 1.01. What is the ratio of the Total Labor Force (in %) of Cameroon in 1992 to that in 1997?
Provide a succinct answer. 0.99. What is the ratio of the Total Labor Force (in %) of Montenegro in 1992 to that in 1997?
Provide a short and direct response. 1.04. What is the ratio of the Total Labor Force (in %) in Qatar in 1992 to that in 1997?
Keep it short and to the point. 1.03. What is the ratio of the Total Labor Force (in %) in Low & middle income in 1993 to that in 1994?
Offer a very short reply. 1. What is the ratio of the Total Labor Force (in %) of Cameroon in 1993 to that in 1994?
Keep it short and to the point. 1. What is the ratio of the Total Labor Force (in %) of Montenegro in 1993 to that in 1994?
Your answer should be very brief. 1.01. What is the ratio of the Total Labor Force (in %) of Qatar in 1993 to that in 1994?
Keep it short and to the point. 1. What is the ratio of the Total Labor Force (in %) in Low & middle income in 1993 to that in 1995?
Provide a short and direct response. 1. What is the ratio of the Total Labor Force (in %) of Cameroon in 1993 to that in 1995?
Your response must be concise. 0.99. What is the ratio of the Total Labor Force (in %) in Montenegro in 1993 to that in 1995?
Your answer should be very brief. 1.02. What is the ratio of the Total Labor Force (in %) in Cameroon in 1993 to that in 1996?
Make the answer very short. 0.99. What is the ratio of the Total Labor Force (in %) in Montenegro in 1993 to that in 1996?
Provide a succinct answer. 1.03. What is the ratio of the Total Labor Force (in %) in Qatar in 1993 to that in 1996?
Keep it short and to the point. 1.02. What is the ratio of the Total Labor Force (in %) in Low & middle income in 1993 to that in 1997?
Give a very brief answer. 1.01. What is the ratio of the Total Labor Force (in %) in Cameroon in 1993 to that in 1997?
Offer a terse response. 0.99. What is the ratio of the Total Labor Force (in %) in Montenegro in 1993 to that in 1997?
Keep it short and to the point. 1.04. What is the ratio of the Total Labor Force (in %) of Qatar in 1993 to that in 1997?
Give a very brief answer. 1.04. What is the ratio of the Total Labor Force (in %) of Montenegro in 1994 to that in 1995?
Offer a terse response. 1.01. What is the ratio of the Total Labor Force (in %) of Montenegro in 1994 to that in 1996?
Keep it short and to the point. 1.02. What is the ratio of the Total Labor Force (in %) of Qatar in 1994 to that in 1996?
Your answer should be compact. 1.02. What is the ratio of the Total Labor Force (in %) of Montenegro in 1994 to that in 1997?
Your response must be concise. 1.03. What is the ratio of the Total Labor Force (in %) of Qatar in 1994 to that in 1997?
Offer a very short reply. 1.03. What is the ratio of the Total Labor Force (in %) of Montenegro in 1995 to that in 1996?
Give a very brief answer. 1.01. What is the ratio of the Total Labor Force (in %) in Montenegro in 1995 to that in 1997?
Give a very brief answer. 1.02. What is the ratio of the Total Labor Force (in %) in Qatar in 1995 to that in 1997?
Give a very brief answer. 1.03. What is the ratio of the Total Labor Force (in %) in Low & middle income in 1996 to that in 1997?
Provide a short and direct response. 1. What is the ratio of the Total Labor Force (in %) in Montenegro in 1996 to that in 1997?
Ensure brevity in your answer.  1.01. What is the ratio of the Total Labor Force (in %) of Qatar in 1996 to that in 1997?
Give a very brief answer. 1.02. What is the difference between the highest and the second highest Total Labor Force (in %) of Low & middle income?
Keep it short and to the point. 0.07. What is the difference between the highest and the second highest Total Labor Force (in %) in Cameroon?
Make the answer very short. 0. What is the difference between the highest and the second highest Total Labor Force (in %) of Qatar?
Give a very brief answer. 0.1. What is the difference between the highest and the lowest Total Labor Force (in %) of Low & middle income?
Offer a very short reply. 0.69. What is the difference between the highest and the lowest Total Labor Force (in %) of Montenegro?
Give a very brief answer. 2.2. What is the difference between the highest and the lowest Total Labor Force (in %) of Qatar?
Provide a short and direct response. 2.8. 